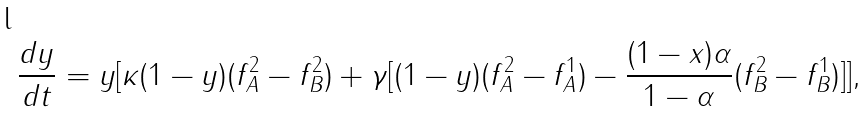Convert formula to latex. <formula><loc_0><loc_0><loc_500><loc_500>\frac { d y } { d t } = y [ \kappa ( 1 - y ) ( f _ { A } ^ { 2 } - f _ { B } ^ { 2 } ) + \gamma [ ( 1 - y ) ( f _ { A } ^ { 2 } - f _ { A } ^ { 1 } ) - \frac { ( 1 - x ) \alpha } { 1 - \alpha } ( f _ { B } ^ { 2 } - f _ { B } ^ { 1 } ) ] ] ,</formula> 